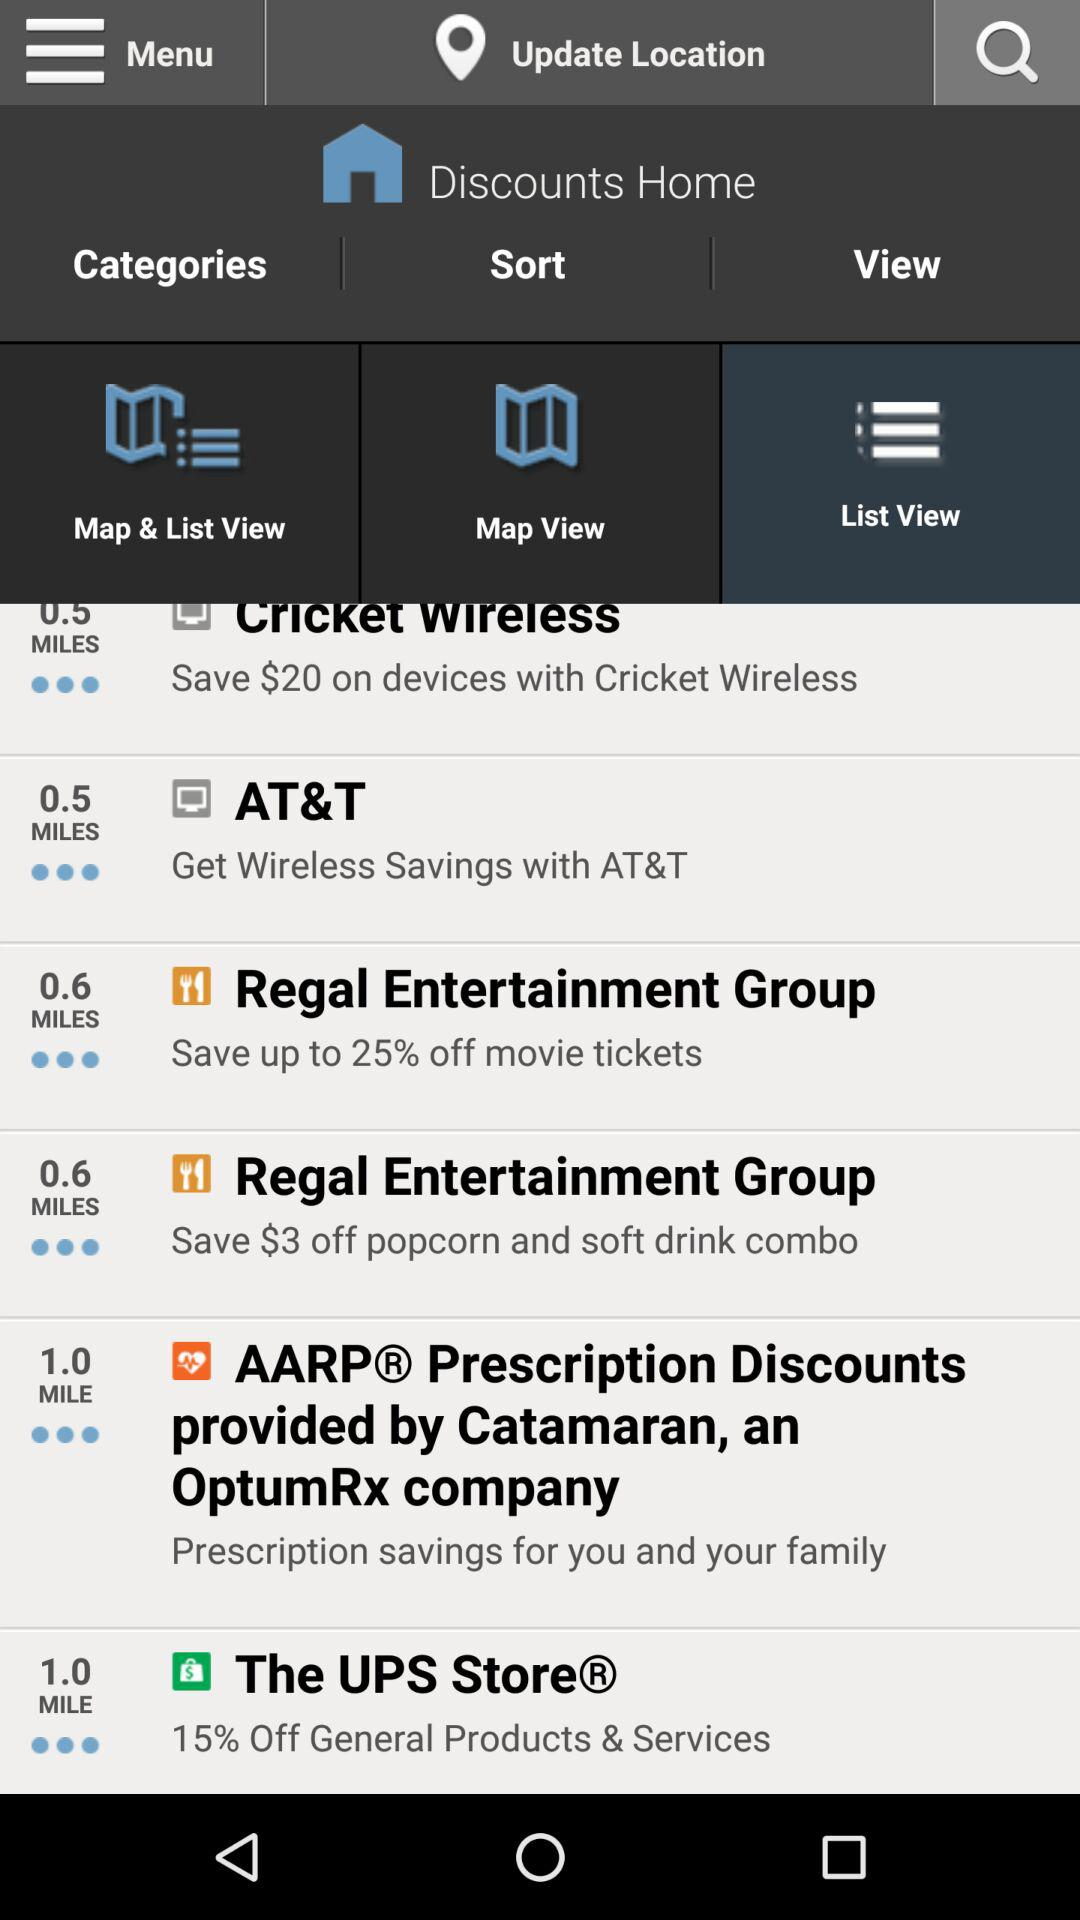How far is "AT&T"? "AT&T" is 0.5 miles away. 